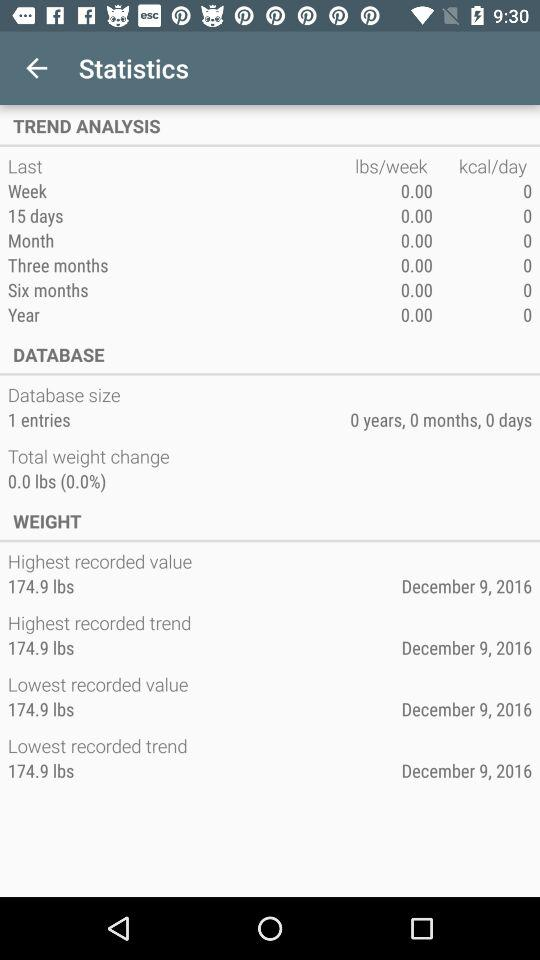What is the highest recorded value? The highest recorded value is 174.9 lbs. 